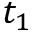Convert formula to latex. <formula><loc_0><loc_0><loc_500><loc_500>t _ { 1 }</formula> 